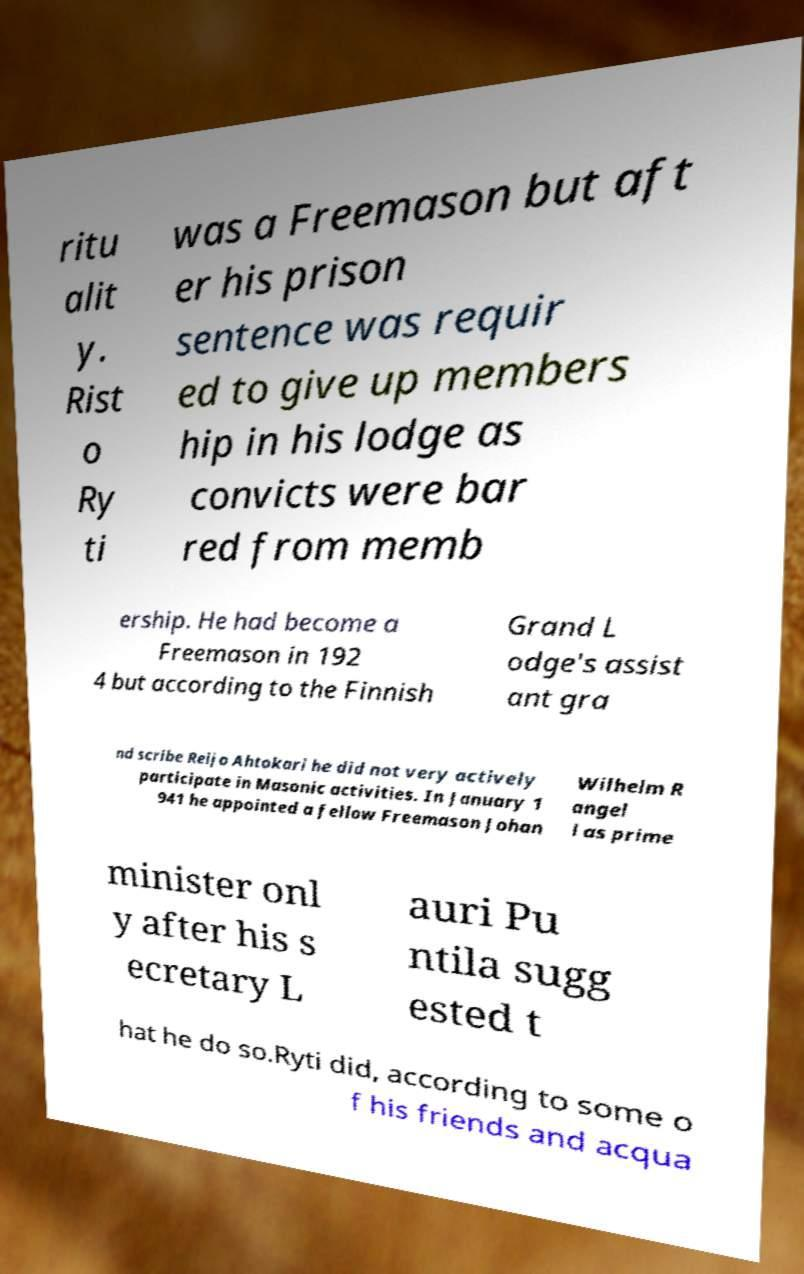What messages or text are displayed in this image? I need them in a readable, typed format. ritu alit y. Rist o Ry ti was a Freemason but aft er his prison sentence was requir ed to give up members hip in his lodge as convicts were bar red from memb ership. He had become a Freemason in 192 4 but according to the Finnish Grand L odge's assist ant gra nd scribe Reijo Ahtokari he did not very actively participate in Masonic activities. In January 1 941 he appointed a fellow Freemason Johan Wilhelm R angel l as prime minister onl y after his s ecretary L auri Pu ntila sugg ested t hat he do so.Ryti did, according to some o f his friends and acqua 